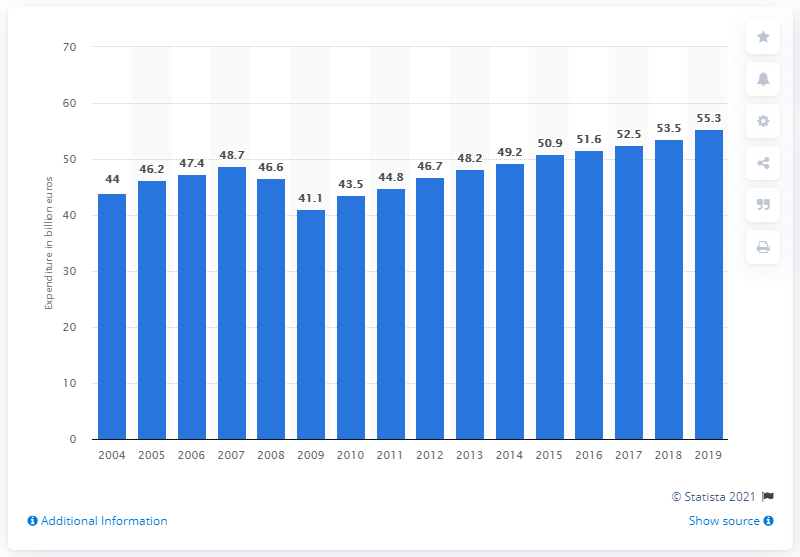Point out several critical features in this image. In 2019, a total of 55.3 billion euros was spent on business travel in Germany. The total spending on business travel in 2008 was 46.7 billion dollars. 